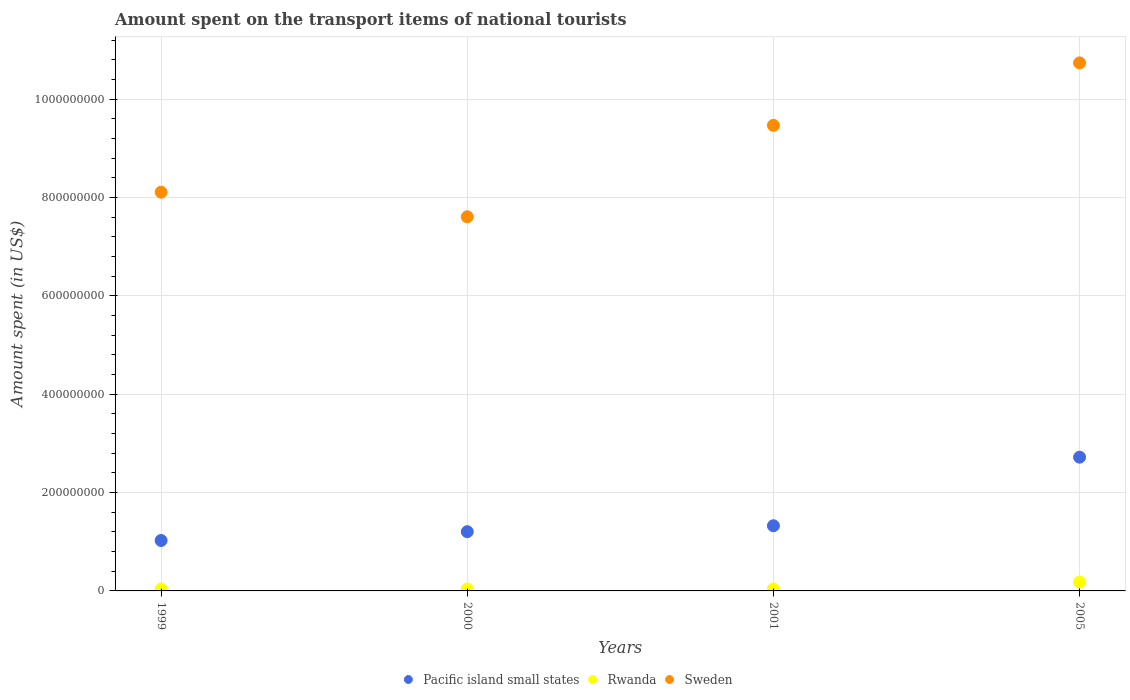Is the number of dotlines equal to the number of legend labels?
Give a very brief answer. Yes. What is the amount spent on the transport items of national tourists in Rwanda in 2001?
Your answer should be compact. 4.00e+06. Across all years, what is the maximum amount spent on the transport items of national tourists in Sweden?
Your answer should be very brief. 1.07e+09. Across all years, what is the minimum amount spent on the transport items of national tourists in Pacific island small states?
Offer a very short reply. 1.03e+08. What is the total amount spent on the transport items of national tourists in Rwanda in the graph?
Your answer should be compact. 3.00e+07. What is the difference between the amount spent on the transport items of national tourists in Pacific island small states in 2000 and that in 2005?
Give a very brief answer. -1.52e+08. What is the difference between the amount spent on the transport items of national tourists in Rwanda in 1999 and the amount spent on the transport items of national tourists in Pacific island small states in 2005?
Make the answer very short. -2.68e+08. What is the average amount spent on the transport items of national tourists in Sweden per year?
Your answer should be very brief. 8.98e+08. In the year 2000, what is the difference between the amount spent on the transport items of national tourists in Rwanda and amount spent on the transport items of national tourists in Pacific island small states?
Ensure brevity in your answer.  -1.17e+08. What is the ratio of the amount spent on the transport items of national tourists in Rwanda in 1999 to that in 2000?
Your response must be concise. 1. Is the difference between the amount spent on the transport items of national tourists in Rwanda in 2000 and 2001 greater than the difference between the amount spent on the transport items of national tourists in Pacific island small states in 2000 and 2001?
Make the answer very short. Yes. What is the difference between the highest and the second highest amount spent on the transport items of national tourists in Pacific island small states?
Keep it short and to the point. 1.40e+08. What is the difference between the highest and the lowest amount spent on the transport items of national tourists in Pacific island small states?
Offer a very short reply. 1.69e+08. Is the sum of the amount spent on the transport items of national tourists in Sweden in 2000 and 2001 greater than the maximum amount spent on the transport items of national tourists in Rwanda across all years?
Your answer should be very brief. Yes. Does the amount spent on the transport items of national tourists in Pacific island small states monotonically increase over the years?
Ensure brevity in your answer.  Yes. Is the amount spent on the transport items of national tourists in Pacific island small states strictly greater than the amount spent on the transport items of national tourists in Sweden over the years?
Ensure brevity in your answer.  No. Is the amount spent on the transport items of national tourists in Rwanda strictly less than the amount spent on the transport items of national tourists in Pacific island small states over the years?
Offer a terse response. Yes. How many years are there in the graph?
Give a very brief answer. 4. Does the graph contain grids?
Give a very brief answer. Yes. Where does the legend appear in the graph?
Give a very brief answer. Bottom center. How many legend labels are there?
Make the answer very short. 3. What is the title of the graph?
Provide a short and direct response. Amount spent on the transport items of national tourists. Does "Europe(all income levels)" appear as one of the legend labels in the graph?
Offer a terse response. No. What is the label or title of the X-axis?
Offer a terse response. Years. What is the label or title of the Y-axis?
Offer a terse response. Amount spent (in US$). What is the Amount spent (in US$) of Pacific island small states in 1999?
Make the answer very short. 1.03e+08. What is the Amount spent (in US$) of Sweden in 1999?
Provide a succinct answer. 8.11e+08. What is the Amount spent (in US$) in Pacific island small states in 2000?
Give a very brief answer. 1.21e+08. What is the Amount spent (in US$) of Rwanda in 2000?
Give a very brief answer. 4.00e+06. What is the Amount spent (in US$) of Sweden in 2000?
Your answer should be very brief. 7.61e+08. What is the Amount spent (in US$) of Pacific island small states in 2001?
Your answer should be compact. 1.33e+08. What is the Amount spent (in US$) of Rwanda in 2001?
Your response must be concise. 4.00e+06. What is the Amount spent (in US$) of Sweden in 2001?
Your response must be concise. 9.47e+08. What is the Amount spent (in US$) of Pacific island small states in 2005?
Your answer should be compact. 2.72e+08. What is the Amount spent (in US$) of Rwanda in 2005?
Your response must be concise. 1.80e+07. What is the Amount spent (in US$) of Sweden in 2005?
Give a very brief answer. 1.07e+09. Across all years, what is the maximum Amount spent (in US$) of Pacific island small states?
Your response must be concise. 2.72e+08. Across all years, what is the maximum Amount spent (in US$) in Rwanda?
Provide a succinct answer. 1.80e+07. Across all years, what is the maximum Amount spent (in US$) in Sweden?
Make the answer very short. 1.07e+09. Across all years, what is the minimum Amount spent (in US$) of Pacific island small states?
Offer a terse response. 1.03e+08. Across all years, what is the minimum Amount spent (in US$) in Rwanda?
Offer a terse response. 4.00e+06. Across all years, what is the minimum Amount spent (in US$) in Sweden?
Offer a terse response. 7.61e+08. What is the total Amount spent (in US$) in Pacific island small states in the graph?
Give a very brief answer. 6.28e+08. What is the total Amount spent (in US$) of Rwanda in the graph?
Provide a short and direct response. 3.00e+07. What is the total Amount spent (in US$) of Sweden in the graph?
Offer a very short reply. 3.59e+09. What is the difference between the Amount spent (in US$) of Pacific island small states in 1999 and that in 2000?
Provide a short and direct response. -1.79e+07. What is the difference between the Amount spent (in US$) of Pacific island small states in 1999 and that in 2001?
Keep it short and to the point. -2.99e+07. What is the difference between the Amount spent (in US$) in Sweden in 1999 and that in 2001?
Offer a terse response. -1.36e+08. What is the difference between the Amount spent (in US$) of Pacific island small states in 1999 and that in 2005?
Ensure brevity in your answer.  -1.69e+08. What is the difference between the Amount spent (in US$) of Rwanda in 1999 and that in 2005?
Your answer should be compact. -1.40e+07. What is the difference between the Amount spent (in US$) of Sweden in 1999 and that in 2005?
Provide a short and direct response. -2.63e+08. What is the difference between the Amount spent (in US$) of Pacific island small states in 2000 and that in 2001?
Offer a terse response. -1.20e+07. What is the difference between the Amount spent (in US$) of Rwanda in 2000 and that in 2001?
Provide a short and direct response. 0. What is the difference between the Amount spent (in US$) of Sweden in 2000 and that in 2001?
Make the answer very short. -1.86e+08. What is the difference between the Amount spent (in US$) of Pacific island small states in 2000 and that in 2005?
Your response must be concise. -1.52e+08. What is the difference between the Amount spent (in US$) in Rwanda in 2000 and that in 2005?
Make the answer very short. -1.40e+07. What is the difference between the Amount spent (in US$) in Sweden in 2000 and that in 2005?
Offer a very short reply. -3.13e+08. What is the difference between the Amount spent (in US$) of Pacific island small states in 2001 and that in 2005?
Ensure brevity in your answer.  -1.40e+08. What is the difference between the Amount spent (in US$) in Rwanda in 2001 and that in 2005?
Your answer should be compact. -1.40e+07. What is the difference between the Amount spent (in US$) in Sweden in 2001 and that in 2005?
Provide a succinct answer. -1.27e+08. What is the difference between the Amount spent (in US$) in Pacific island small states in 1999 and the Amount spent (in US$) in Rwanda in 2000?
Make the answer very short. 9.86e+07. What is the difference between the Amount spent (in US$) of Pacific island small states in 1999 and the Amount spent (in US$) of Sweden in 2000?
Keep it short and to the point. -6.58e+08. What is the difference between the Amount spent (in US$) of Rwanda in 1999 and the Amount spent (in US$) of Sweden in 2000?
Provide a succinct answer. -7.57e+08. What is the difference between the Amount spent (in US$) of Pacific island small states in 1999 and the Amount spent (in US$) of Rwanda in 2001?
Provide a short and direct response. 9.86e+07. What is the difference between the Amount spent (in US$) of Pacific island small states in 1999 and the Amount spent (in US$) of Sweden in 2001?
Keep it short and to the point. -8.44e+08. What is the difference between the Amount spent (in US$) in Rwanda in 1999 and the Amount spent (in US$) in Sweden in 2001?
Your answer should be very brief. -9.43e+08. What is the difference between the Amount spent (in US$) of Pacific island small states in 1999 and the Amount spent (in US$) of Rwanda in 2005?
Ensure brevity in your answer.  8.46e+07. What is the difference between the Amount spent (in US$) of Pacific island small states in 1999 and the Amount spent (in US$) of Sweden in 2005?
Offer a terse response. -9.71e+08. What is the difference between the Amount spent (in US$) of Rwanda in 1999 and the Amount spent (in US$) of Sweden in 2005?
Offer a terse response. -1.07e+09. What is the difference between the Amount spent (in US$) of Pacific island small states in 2000 and the Amount spent (in US$) of Rwanda in 2001?
Give a very brief answer. 1.17e+08. What is the difference between the Amount spent (in US$) of Pacific island small states in 2000 and the Amount spent (in US$) of Sweden in 2001?
Your response must be concise. -8.26e+08. What is the difference between the Amount spent (in US$) of Rwanda in 2000 and the Amount spent (in US$) of Sweden in 2001?
Offer a terse response. -9.43e+08. What is the difference between the Amount spent (in US$) in Pacific island small states in 2000 and the Amount spent (in US$) in Rwanda in 2005?
Your answer should be compact. 1.03e+08. What is the difference between the Amount spent (in US$) in Pacific island small states in 2000 and the Amount spent (in US$) in Sweden in 2005?
Provide a short and direct response. -9.53e+08. What is the difference between the Amount spent (in US$) in Rwanda in 2000 and the Amount spent (in US$) in Sweden in 2005?
Your response must be concise. -1.07e+09. What is the difference between the Amount spent (in US$) in Pacific island small states in 2001 and the Amount spent (in US$) in Rwanda in 2005?
Your answer should be very brief. 1.15e+08. What is the difference between the Amount spent (in US$) in Pacific island small states in 2001 and the Amount spent (in US$) in Sweden in 2005?
Provide a succinct answer. -9.41e+08. What is the difference between the Amount spent (in US$) in Rwanda in 2001 and the Amount spent (in US$) in Sweden in 2005?
Provide a short and direct response. -1.07e+09. What is the average Amount spent (in US$) in Pacific island small states per year?
Your answer should be very brief. 1.57e+08. What is the average Amount spent (in US$) in Rwanda per year?
Provide a succinct answer. 7.50e+06. What is the average Amount spent (in US$) in Sweden per year?
Offer a very short reply. 8.98e+08. In the year 1999, what is the difference between the Amount spent (in US$) of Pacific island small states and Amount spent (in US$) of Rwanda?
Your answer should be compact. 9.86e+07. In the year 1999, what is the difference between the Amount spent (in US$) of Pacific island small states and Amount spent (in US$) of Sweden?
Offer a terse response. -7.08e+08. In the year 1999, what is the difference between the Amount spent (in US$) of Rwanda and Amount spent (in US$) of Sweden?
Give a very brief answer. -8.07e+08. In the year 2000, what is the difference between the Amount spent (in US$) of Pacific island small states and Amount spent (in US$) of Rwanda?
Your answer should be compact. 1.17e+08. In the year 2000, what is the difference between the Amount spent (in US$) in Pacific island small states and Amount spent (in US$) in Sweden?
Your response must be concise. -6.40e+08. In the year 2000, what is the difference between the Amount spent (in US$) of Rwanda and Amount spent (in US$) of Sweden?
Ensure brevity in your answer.  -7.57e+08. In the year 2001, what is the difference between the Amount spent (in US$) in Pacific island small states and Amount spent (in US$) in Rwanda?
Provide a succinct answer. 1.29e+08. In the year 2001, what is the difference between the Amount spent (in US$) in Pacific island small states and Amount spent (in US$) in Sweden?
Provide a succinct answer. -8.14e+08. In the year 2001, what is the difference between the Amount spent (in US$) of Rwanda and Amount spent (in US$) of Sweden?
Offer a very short reply. -9.43e+08. In the year 2005, what is the difference between the Amount spent (in US$) in Pacific island small states and Amount spent (in US$) in Rwanda?
Keep it short and to the point. 2.54e+08. In the year 2005, what is the difference between the Amount spent (in US$) of Pacific island small states and Amount spent (in US$) of Sweden?
Ensure brevity in your answer.  -8.02e+08. In the year 2005, what is the difference between the Amount spent (in US$) in Rwanda and Amount spent (in US$) in Sweden?
Offer a terse response. -1.06e+09. What is the ratio of the Amount spent (in US$) in Pacific island small states in 1999 to that in 2000?
Your answer should be very brief. 0.85. What is the ratio of the Amount spent (in US$) in Sweden in 1999 to that in 2000?
Your response must be concise. 1.07. What is the ratio of the Amount spent (in US$) of Pacific island small states in 1999 to that in 2001?
Provide a succinct answer. 0.77. What is the ratio of the Amount spent (in US$) in Rwanda in 1999 to that in 2001?
Make the answer very short. 1. What is the ratio of the Amount spent (in US$) in Sweden in 1999 to that in 2001?
Your response must be concise. 0.86. What is the ratio of the Amount spent (in US$) in Pacific island small states in 1999 to that in 2005?
Offer a very short reply. 0.38. What is the ratio of the Amount spent (in US$) in Rwanda in 1999 to that in 2005?
Provide a succinct answer. 0.22. What is the ratio of the Amount spent (in US$) in Sweden in 1999 to that in 2005?
Your answer should be compact. 0.76. What is the ratio of the Amount spent (in US$) of Pacific island small states in 2000 to that in 2001?
Your answer should be very brief. 0.91. What is the ratio of the Amount spent (in US$) in Sweden in 2000 to that in 2001?
Give a very brief answer. 0.8. What is the ratio of the Amount spent (in US$) in Pacific island small states in 2000 to that in 2005?
Give a very brief answer. 0.44. What is the ratio of the Amount spent (in US$) in Rwanda in 2000 to that in 2005?
Your answer should be very brief. 0.22. What is the ratio of the Amount spent (in US$) in Sweden in 2000 to that in 2005?
Give a very brief answer. 0.71. What is the ratio of the Amount spent (in US$) of Pacific island small states in 2001 to that in 2005?
Your response must be concise. 0.49. What is the ratio of the Amount spent (in US$) in Rwanda in 2001 to that in 2005?
Give a very brief answer. 0.22. What is the ratio of the Amount spent (in US$) in Sweden in 2001 to that in 2005?
Make the answer very short. 0.88. What is the difference between the highest and the second highest Amount spent (in US$) of Pacific island small states?
Offer a very short reply. 1.40e+08. What is the difference between the highest and the second highest Amount spent (in US$) of Rwanda?
Ensure brevity in your answer.  1.40e+07. What is the difference between the highest and the second highest Amount spent (in US$) of Sweden?
Offer a terse response. 1.27e+08. What is the difference between the highest and the lowest Amount spent (in US$) of Pacific island small states?
Your response must be concise. 1.69e+08. What is the difference between the highest and the lowest Amount spent (in US$) of Rwanda?
Ensure brevity in your answer.  1.40e+07. What is the difference between the highest and the lowest Amount spent (in US$) of Sweden?
Offer a very short reply. 3.13e+08. 